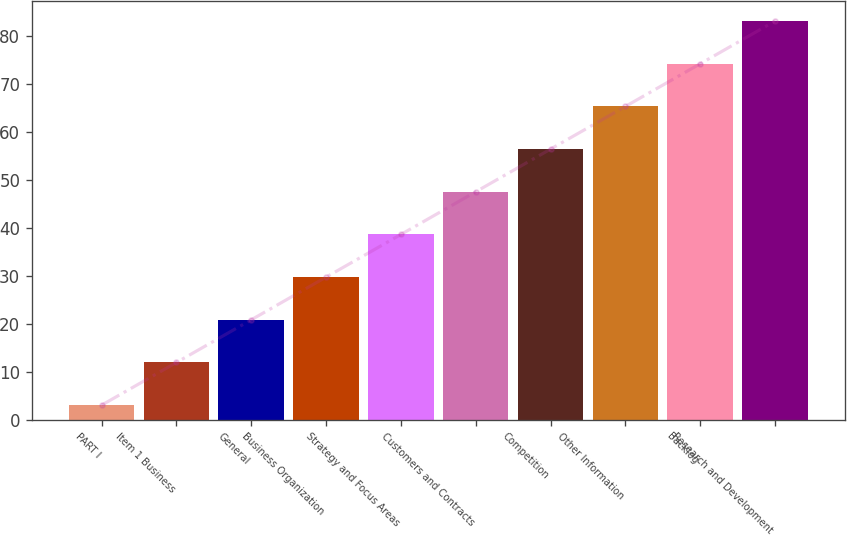Convert chart. <chart><loc_0><loc_0><loc_500><loc_500><bar_chart><fcel>PART I<fcel>Item 1 Business<fcel>General<fcel>Business Organization<fcel>Strategy and Focus Areas<fcel>Customers and Contracts<fcel>Competition<fcel>Other Information<fcel>Backlog<fcel>Research and Development<nl><fcel>3<fcel>11.9<fcel>20.8<fcel>29.7<fcel>38.6<fcel>47.5<fcel>56.4<fcel>65.3<fcel>74.2<fcel>83.1<nl></chart> 